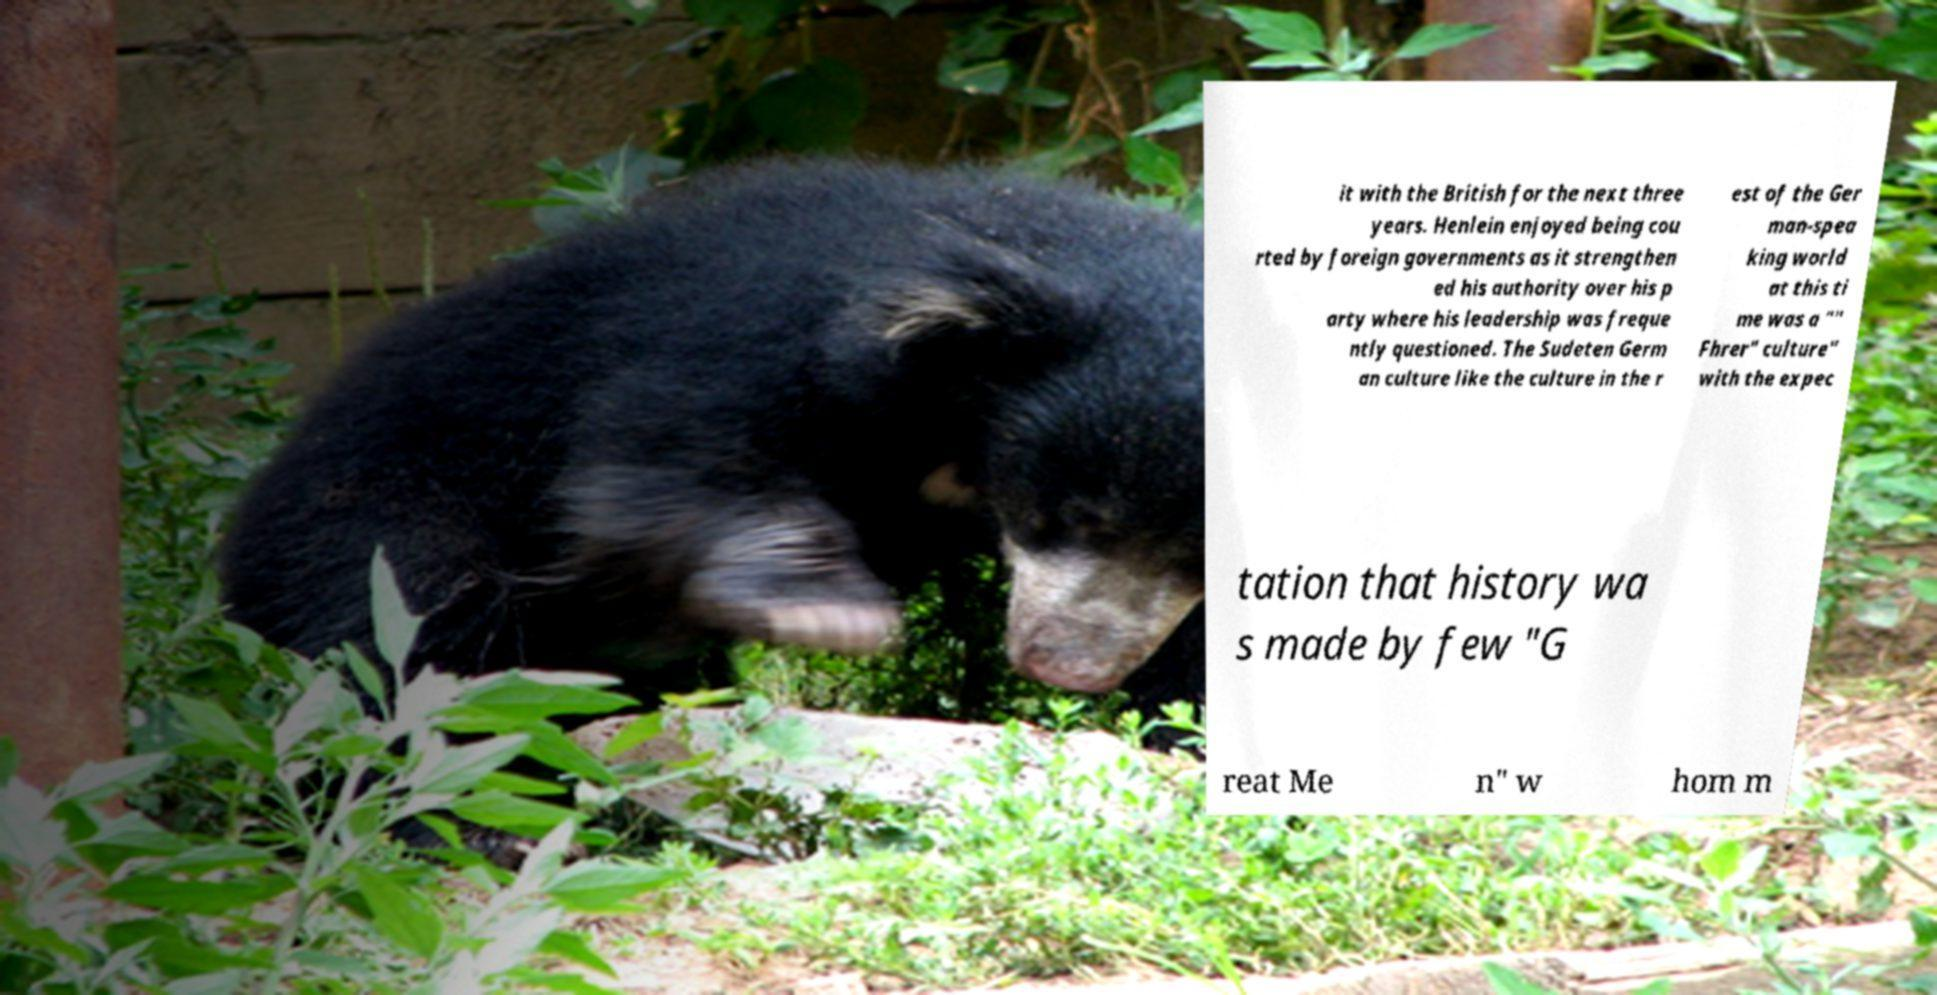Could you extract and type out the text from this image? it with the British for the next three years. Henlein enjoyed being cou rted by foreign governments as it strengthen ed his authority over his p arty where his leadership was freque ntly questioned. The Sudeten Germ an culture like the culture in the r est of the Ger man-spea king world at this ti me was a "" Fhrer" culture" with the expec tation that history wa s made by few "G reat Me n" w hom m 